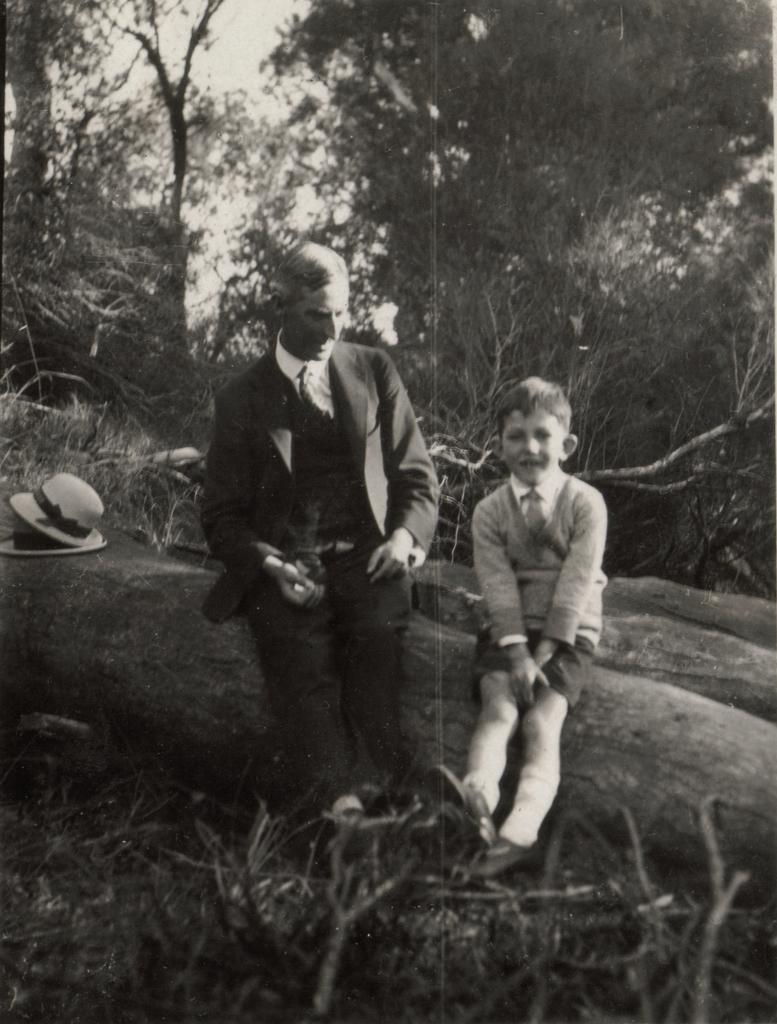How many people are present in the image? There are two persons sitting in the image. What can be seen in the background of the image? There are trees and the sky visible in the background of the image. What is the color scheme of the image? The image is in black and white. What type of seed can be seen growing in the quicksand in the image? There is no seed or quicksand present in the image; it features two persons sitting with trees and the sky in the background. 